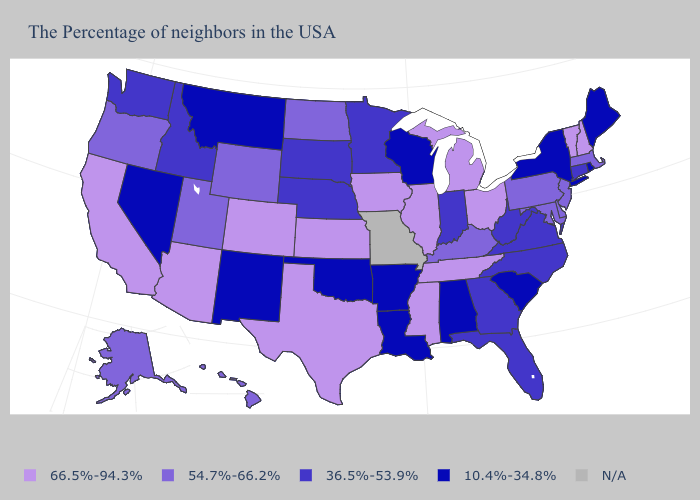Among the states that border New Mexico , which have the highest value?
Write a very short answer. Texas, Colorado, Arizona. What is the highest value in the USA?
Short answer required. 66.5%-94.3%. Does South Carolina have the highest value in the USA?
Answer briefly. No. What is the value of Missouri?
Be succinct. N/A. Does Maryland have the highest value in the USA?
Quick response, please. No. Which states have the highest value in the USA?
Short answer required. New Hampshire, Vermont, Ohio, Michigan, Tennessee, Illinois, Mississippi, Iowa, Kansas, Texas, Colorado, Arizona, California. Which states have the lowest value in the MidWest?
Write a very short answer. Wisconsin. Name the states that have a value in the range 10.4%-34.8%?
Be succinct. Maine, Rhode Island, New York, South Carolina, Alabama, Wisconsin, Louisiana, Arkansas, Oklahoma, New Mexico, Montana, Nevada. How many symbols are there in the legend?
Write a very short answer. 5. What is the lowest value in the West?
Concise answer only. 10.4%-34.8%. Does the map have missing data?
Answer briefly. Yes. What is the value of Maine?
Write a very short answer. 10.4%-34.8%. 